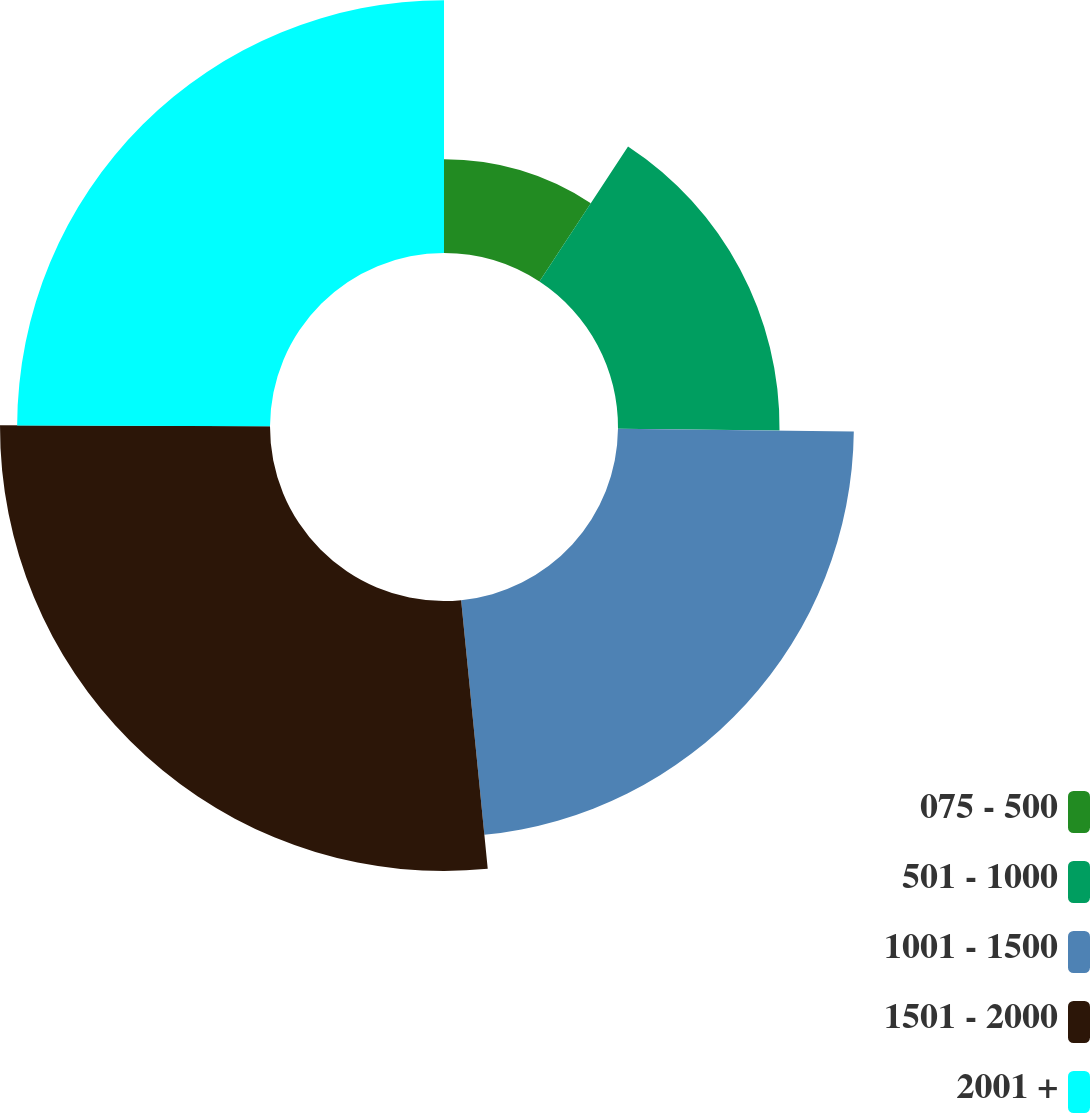Convert chart to OTSL. <chart><loc_0><loc_0><loc_500><loc_500><pie_chart><fcel>075 - 500<fcel>501 - 1000<fcel>1001 - 1500<fcel>1501 - 2000<fcel>2001 +<nl><fcel>9.24%<fcel>15.93%<fcel>23.26%<fcel>26.63%<fcel>24.94%<nl></chart> 